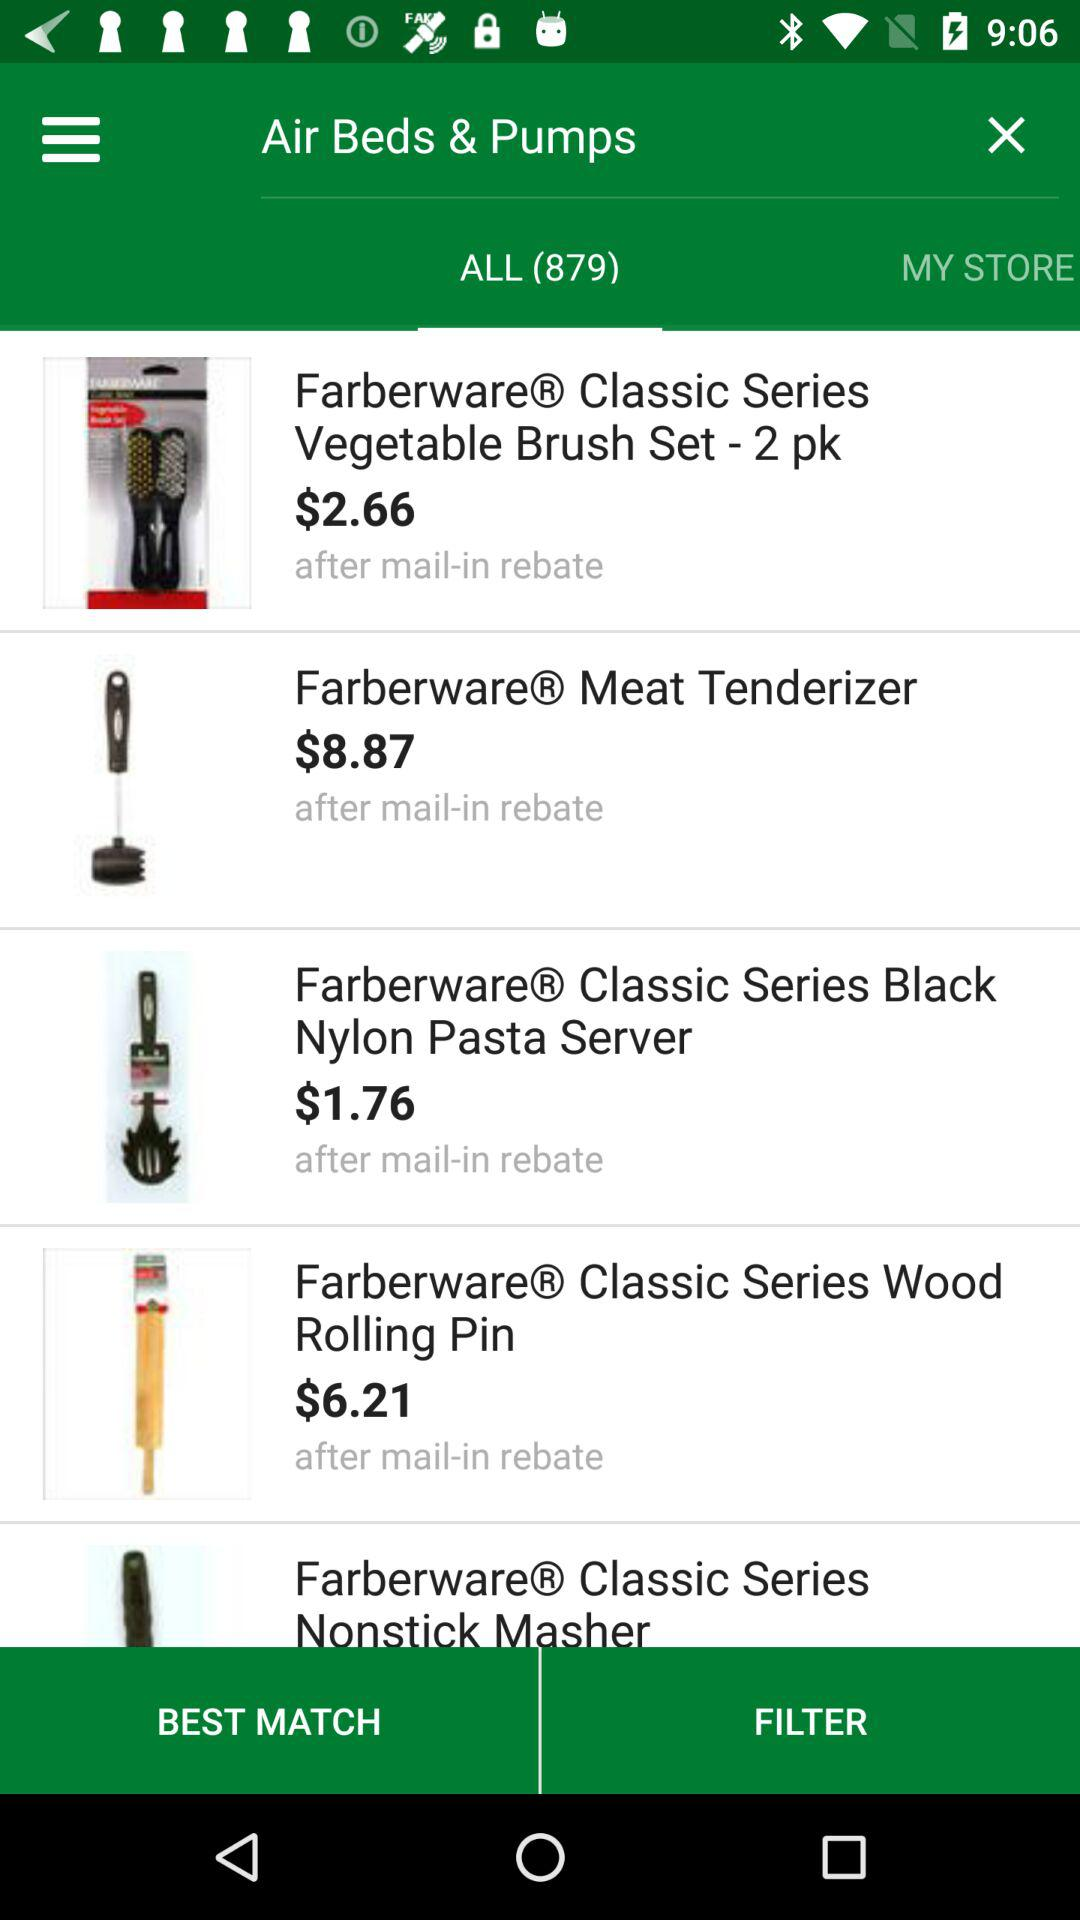What is the cost of meat tenderizer? The cost of meat tenderizer is $8.87. 